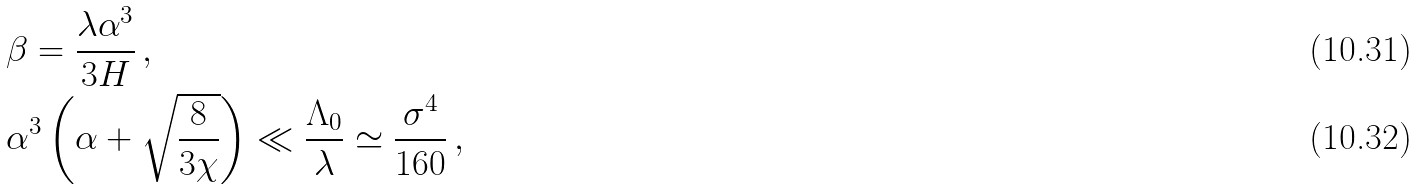Convert formula to latex. <formula><loc_0><loc_0><loc_500><loc_500>& \beta = \frac { \lambda \alpha ^ { 3 } } { 3 H } \, , \\ & \alpha ^ { 3 } \left ( \alpha + \sqrt { \frac { 8 } { 3 \chi } } \right ) \ll \frac { \Lambda _ { 0 } } { \lambda } \simeq \frac { \sigma ^ { 4 } } { 1 6 0 } \, ,</formula> 